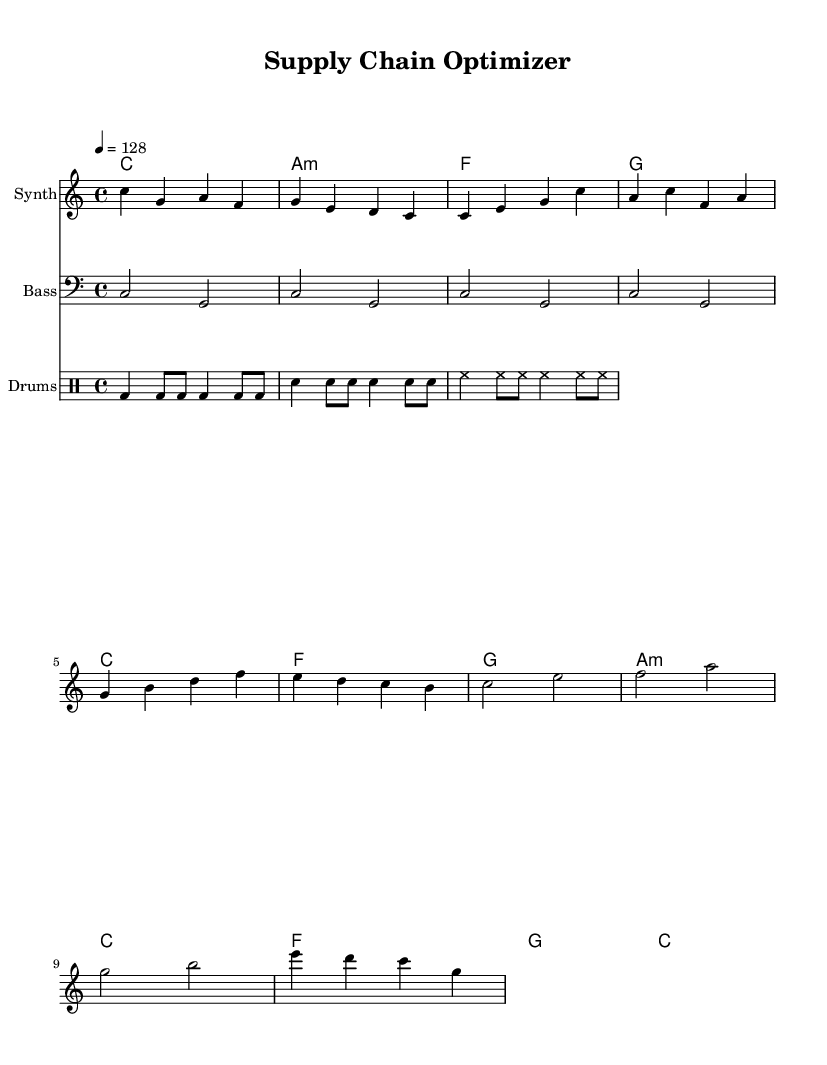What is the key signature of this music? The key signature is indicated at the beginning of the staff, showing C major, which typically has no sharps or flats.
Answer: C major What is the time signature of this music? The time signature is found at the beginning of the score, and it shows 4/4, meaning there are four beats in a measure.
Answer: 4/4 What is the tempo of this music? The tempo marking shows 4 equals 128, indicating that there are 128 beats per minute in the piece.
Answer: 128 How many bars are in the intro? By counting the segments in the intro section of the sheet music, we see there are 4 bars indicated.
Answer: 4 Which instrument has the melody? Examining the score, we can see that the staff labeled "Synth" carries the melody, distinguishing it from bass and drums.
Answer: Synth What is the pattern of the bass line? The bass line consists of a repeated pattern that alternates between the notes C and G, covering 4 bars as shown in the bass staff.
Answer: C and G How does the harmony change between the verses and the chorus? During the verses, the harmony moves through C, F, G, and A minor, while in the chorus it shifts to C, F, G, and C, indicating a change in structure and resolution.
Answer: C, F, G, C 